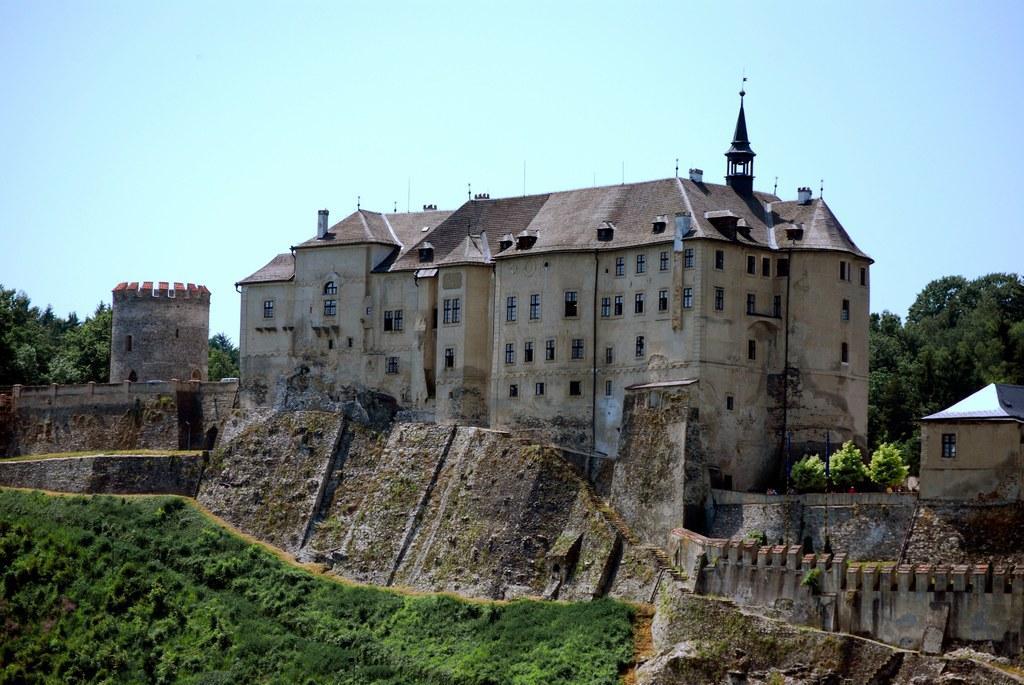Describe this image in one or two sentences. In the center of the image we can see the sky, buildings, windows, trees, grass and a few other objects. 